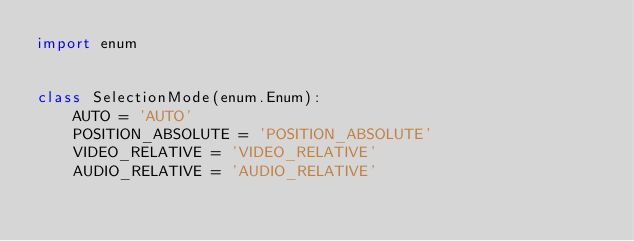Convert code to text. <code><loc_0><loc_0><loc_500><loc_500><_Python_>import enum


class SelectionMode(enum.Enum):
    AUTO = 'AUTO'
    POSITION_ABSOLUTE = 'POSITION_ABSOLUTE'
    VIDEO_RELATIVE = 'VIDEO_RELATIVE'
    AUDIO_RELATIVE = 'AUDIO_RELATIVE'
</code> 